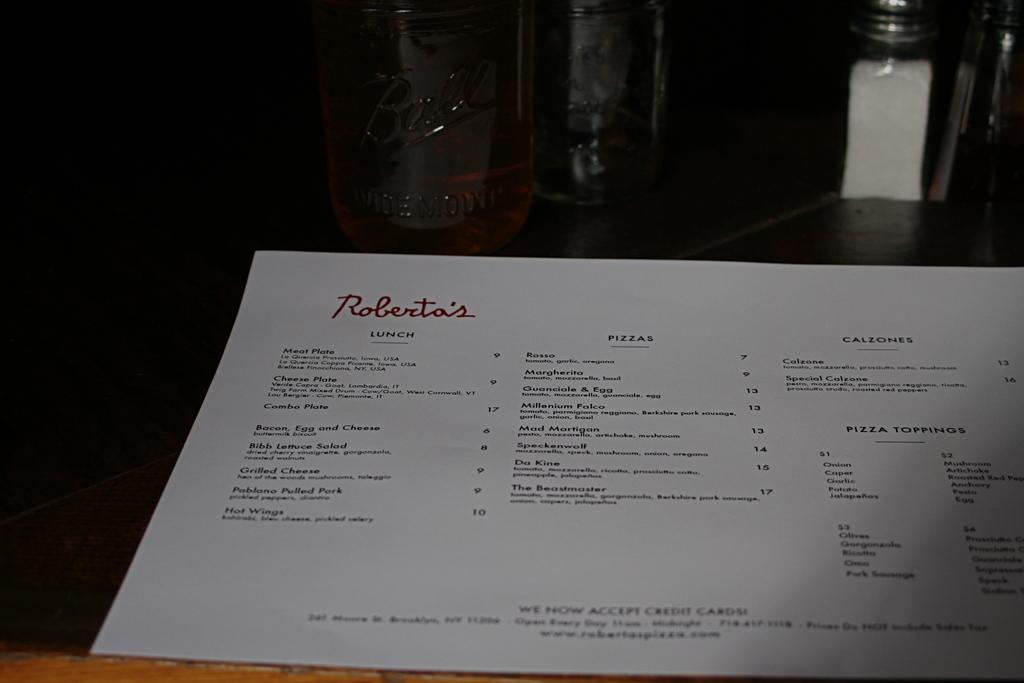What is the name of this restaurant?
Provide a short and direct response. Roberta's. 